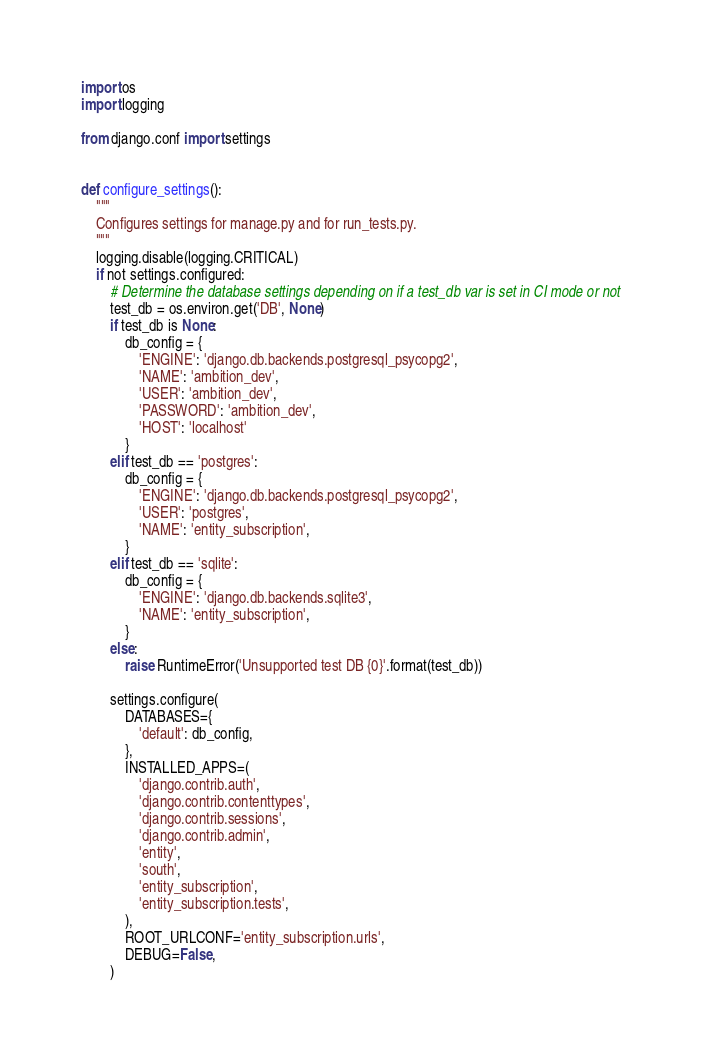Convert code to text. <code><loc_0><loc_0><loc_500><loc_500><_Python_>import os
import logging

from django.conf import settings


def configure_settings():
    """
    Configures settings for manage.py and for run_tests.py.
    """
    logging.disable(logging.CRITICAL)
    if not settings.configured:
        # Determine the database settings depending on if a test_db var is set in CI mode or not
        test_db = os.environ.get('DB', None)
        if test_db is None:
            db_config = {
                'ENGINE': 'django.db.backends.postgresql_psycopg2',
                'NAME': 'ambition_dev',
                'USER': 'ambition_dev',
                'PASSWORD': 'ambition_dev',
                'HOST': 'localhost'
            }
        elif test_db == 'postgres':
            db_config = {
                'ENGINE': 'django.db.backends.postgresql_psycopg2',
                'USER': 'postgres',
                'NAME': 'entity_subscription',
            }
        elif test_db == 'sqlite':
            db_config = {
                'ENGINE': 'django.db.backends.sqlite3',
                'NAME': 'entity_subscription',
            }
        else:
            raise RuntimeError('Unsupported test DB {0}'.format(test_db))

        settings.configure(
            DATABASES={
                'default': db_config,
            },
            INSTALLED_APPS=(
                'django.contrib.auth',
                'django.contrib.contenttypes',
                'django.contrib.sessions',
                'django.contrib.admin',
                'entity',
                'south',
                'entity_subscription',
                'entity_subscription.tests',
            ),
            ROOT_URLCONF='entity_subscription.urls',
            DEBUG=False,
        )
</code> 